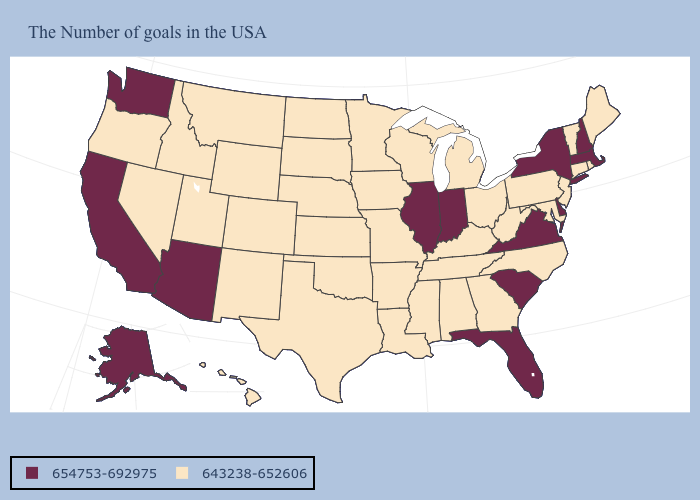Which states have the highest value in the USA?
Short answer required. Massachusetts, New Hampshire, New York, Delaware, Virginia, South Carolina, Florida, Indiana, Illinois, Arizona, California, Washington, Alaska. Among the states that border Wyoming , which have the lowest value?
Give a very brief answer. Nebraska, South Dakota, Colorado, Utah, Montana, Idaho. Name the states that have a value in the range 643238-652606?
Short answer required. Maine, Rhode Island, Vermont, Connecticut, New Jersey, Maryland, Pennsylvania, North Carolina, West Virginia, Ohio, Georgia, Michigan, Kentucky, Alabama, Tennessee, Wisconsin, Mississippi, Louisiana, Missouri, Arkansas, Minnesota, Iowa, Kansas, Nebraska, Oklahoma, Texas, South Dakota, North Dakota, Wyoming, Colorado, New Mexico, Utah, Montana, Idaho, Nevada, Oregon, Hawaii. Name the states that have a value in the range 654753-692975?
Keep it brief. Massachusetts, New Hampshire, New York, Delaware, Virginia, South Carolina, Florida, Indiana, Illinois, Arizona, California, Washington, Alaska. What is the lowest value in the West?
Write a very short answer. 643238-652606. Does the first symbol in the legend represent the smallest category?
Short answer required. No. Does Illinois have the same value as Washington?
Keep it brief. Yes. What is the lowest value in states that border North Carolina?
Be succinct. 643238-652606. Which states have the lowest value in the West?
Keep it brief. Wyoming, Colorado, New Mexico, Utah, Montana, Idaho, Nevada, Oregon, Hawaii. How many symbols are there in the legend?
Answer briefly. 2. What is the value of Georgia?
Short answer required. 643238-652606. What is the value of New Hampshire?
Keep it brief. 654753-692975. Which states have the lowest value in the MidWest?
Keep it brief. Ohio, Michigan, Wisconsin, Missouri, Minnesota, Iowa, Kansas, Nebraska, South Dakota, North Dakota. 